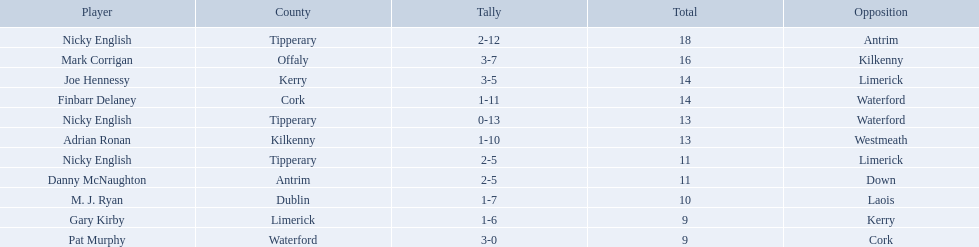Which of the following players were ranked in the bottom 5? Nicky English, Danny McNaughton, M. J. Ryan, Gary Kirby, Pat Murphy. Of these, whose tallies were not 2-5? M. J. Ryan, Gary Kirby, Pat Murphy. From the above three, which one scored more than 9 total points? M. J. Ryan. 